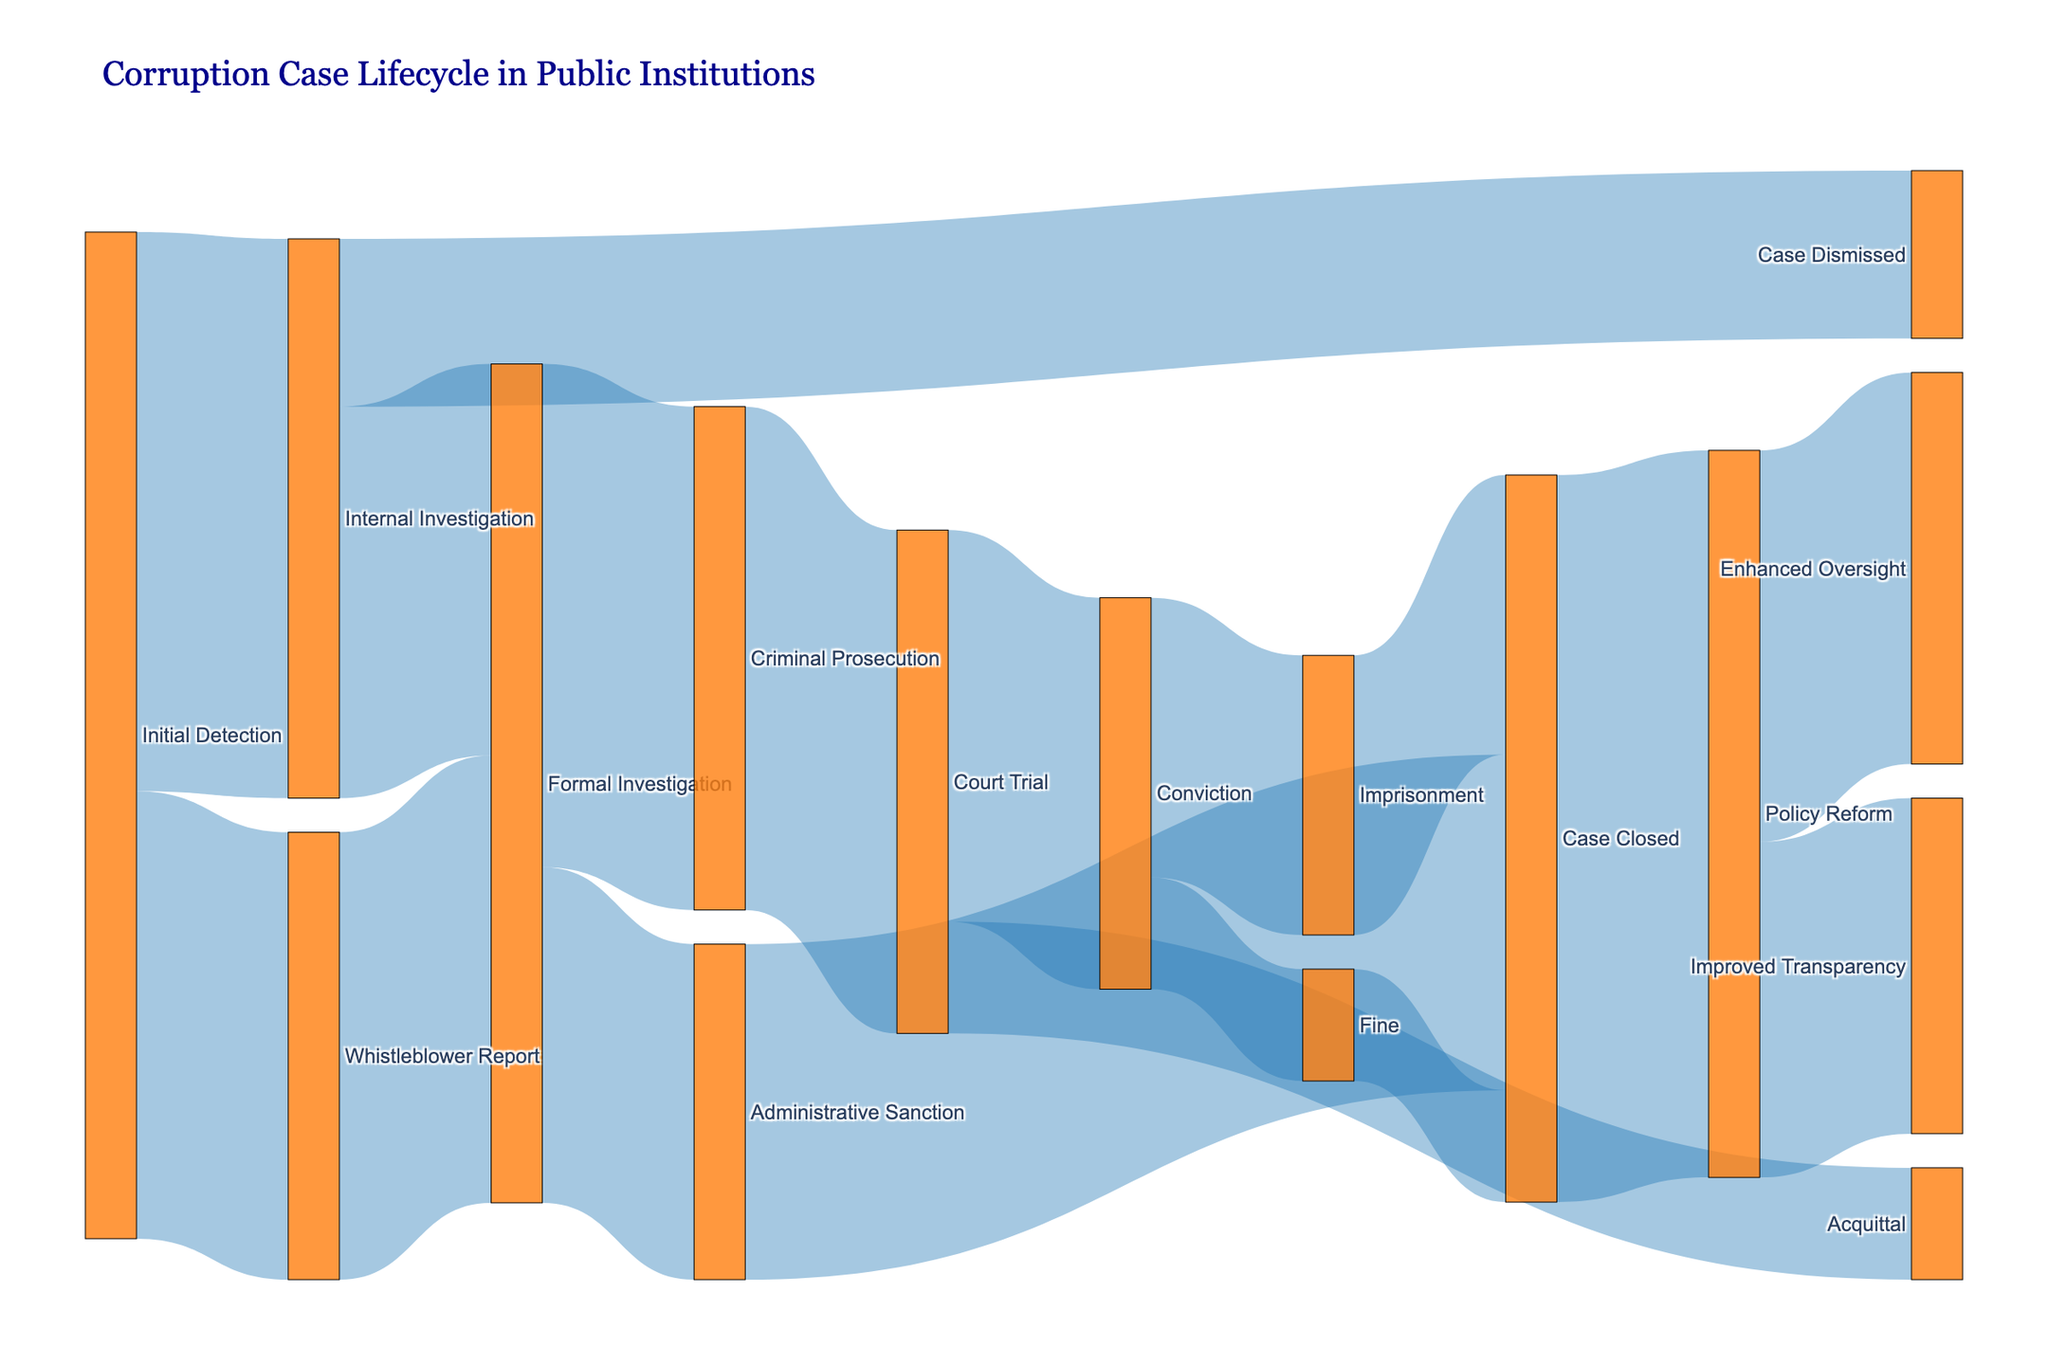What are the main stages after 'Initial Detection' in the corruption case lifecycle? The diagram shows two primary flows stemming from 'Initial Detection': 'Internal Investigation' and 'Whistleblower Report'.
Answer: 'Internal Investigation' and 'Whistleblower Report' How many cases result in an 'Administrative Sanction' following a 'Formal Investigation'? According to the diagram, 60 cases flow from 'Formal Investigation' to 'Administrative Sanction'.
Answer: 60 Which stage receives the highest number of cases after 'Formal Investigation'? The diagram indicates two flows from 'Formal Investigation': 'Administrative Sanction' with 60 cases and 'Criminal Prosecution' with 90 cases. Thus, 'Criminal Prosecution' has the most cases.
Answer: 'Criminal Prosecution' with 90 cases What is the total number of cases that reach 'Court Trial'? Both 'Criminal Prosecution' flows into 'Court Trial' with 90 cases.
Answer: 90 How many cases result in 'Conviction' after 'Court Trial'? The diagram shows that out of 'Court Trial', 70 cases result in 'Conviction'.
Answer: 70 How many cases lead to 'Policy Reform' after being 'Closed'? The diagram highlights that 130 cases flow from 'Case Closed' to 'Policy Reform'.
Answer: 130 What are the different outcomes after a 'Conviction'? According to the diagram, 'Conviction' leads to two outcomes: 'Imprisonment' with 50 cases and 'Fine' with 20 cases.
Answer: 'Imprisonment' and 'Fine' How many cases end up in 'Case Closed' after 'Imprisonment' and 'Fine' combined? The diagram indicates that 50 cases from 'Imprisonment' and 20 cases from 'Fine' end up in 'Case Closed'. Summing these, the total is 70.
Answer: 70 What stages follow after 'Policy Reform'? The diagram shows two flows from 'Policy Reform': 'Enhanced Oversight' with 70 cases and 'Improved Transparency' with 60 cases.
Answer: 'Enhanced Oversight' and 'Improved Transparency' 